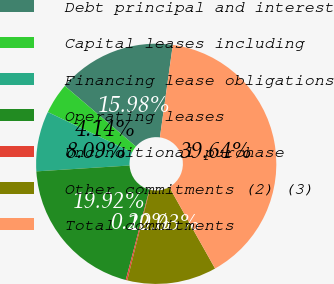Convert chart to OTSL. <chart><loc_0><loc_0><loc_500><loc_500><pie_chart><fcel>Debt principal and interest<fcel>Capital leases including<fcel>Financing lease obligations<fcel>Operating leases<fcel>Unconditional purchase<fcel>Other commitments (2) (3)<fcel>Total commitments<nl><fcel>15.98%<fcel>4.14%<fcel>8.09%<fcel>19.92%<fcel>0.2%<fcel>12.03%<fcel>39.64%<nl></chart> 